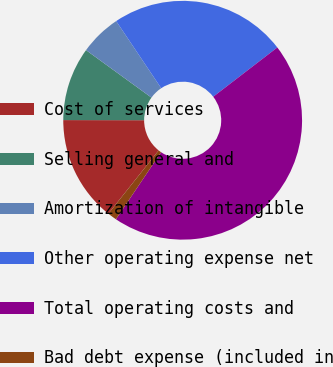Convert chart. <chart><loc_0><loc_0><loc_500><loc_500><pie_chart><fcel>Cost of services<fcel>Selling general and<fcel>Amortization of intangible<fcel>Other operating expense net<fcel>Total operating costs and<fcel>Bad debt expense (included in<nl><fcel>14.33%<fcel>9.97%<fcel>5.61%<fcel>23.97%<fcel>44.88%<fcel>1.25%<nl></chart> 